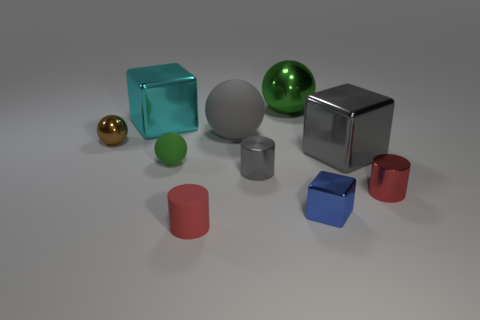Subtract all cubes. How many objects are left? 7 Subtract 0 cyan balls. How many objects are left? 10 Subtract all large yellow metallic blocks. Subtract all tiny red rubber cylinders. How many objects are left? 9 Add 5 rubber balls. How many rubber balls are left? 7 Add 6 blue rubber spheres. How many blue rubber spheres exist? 6 